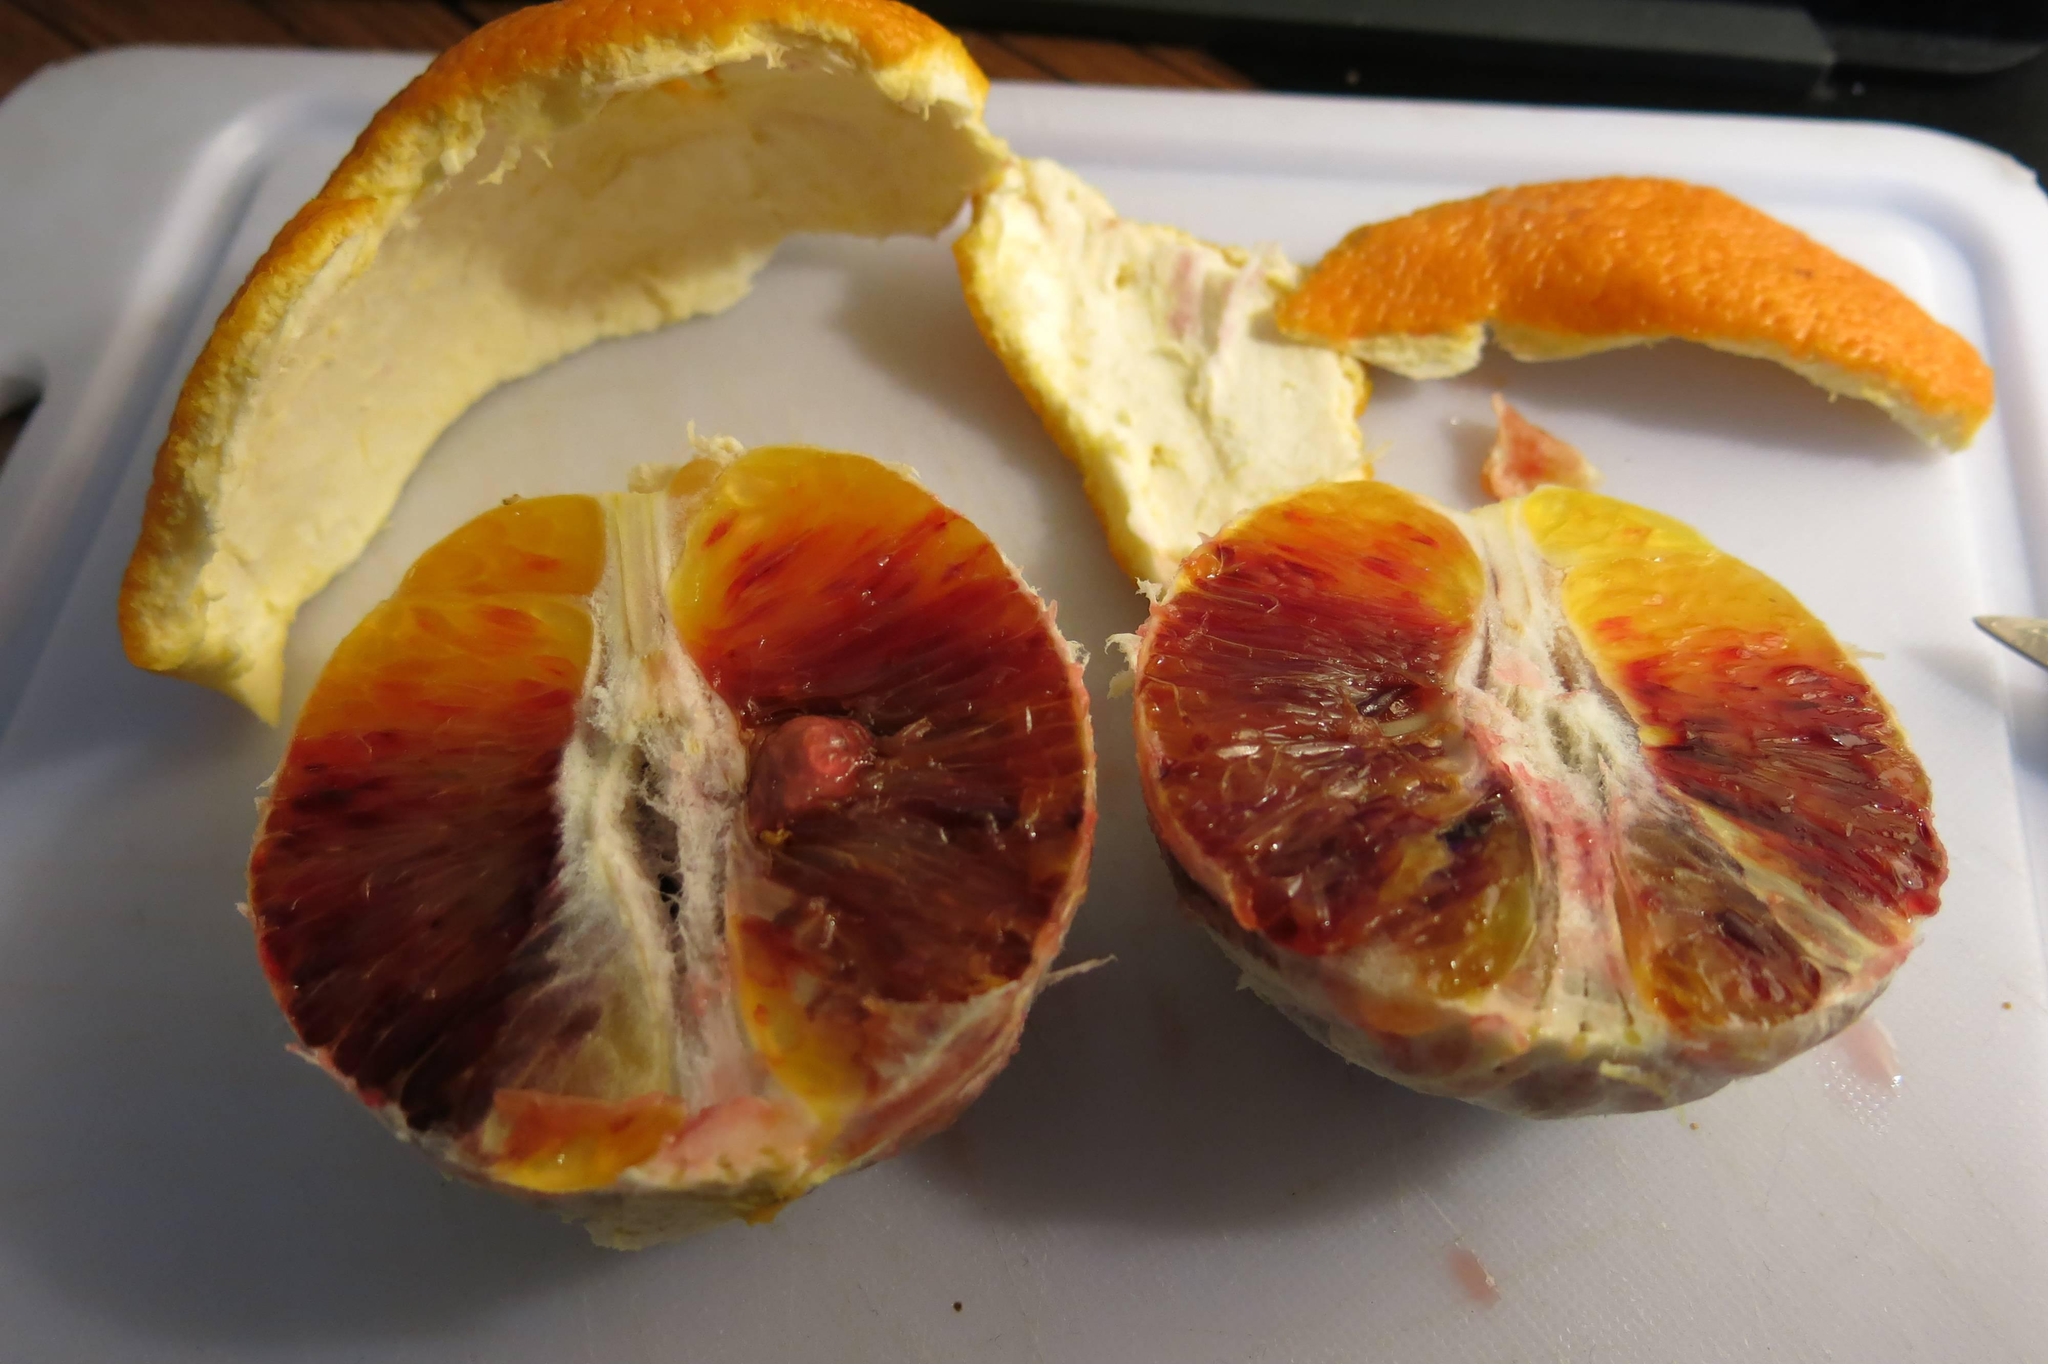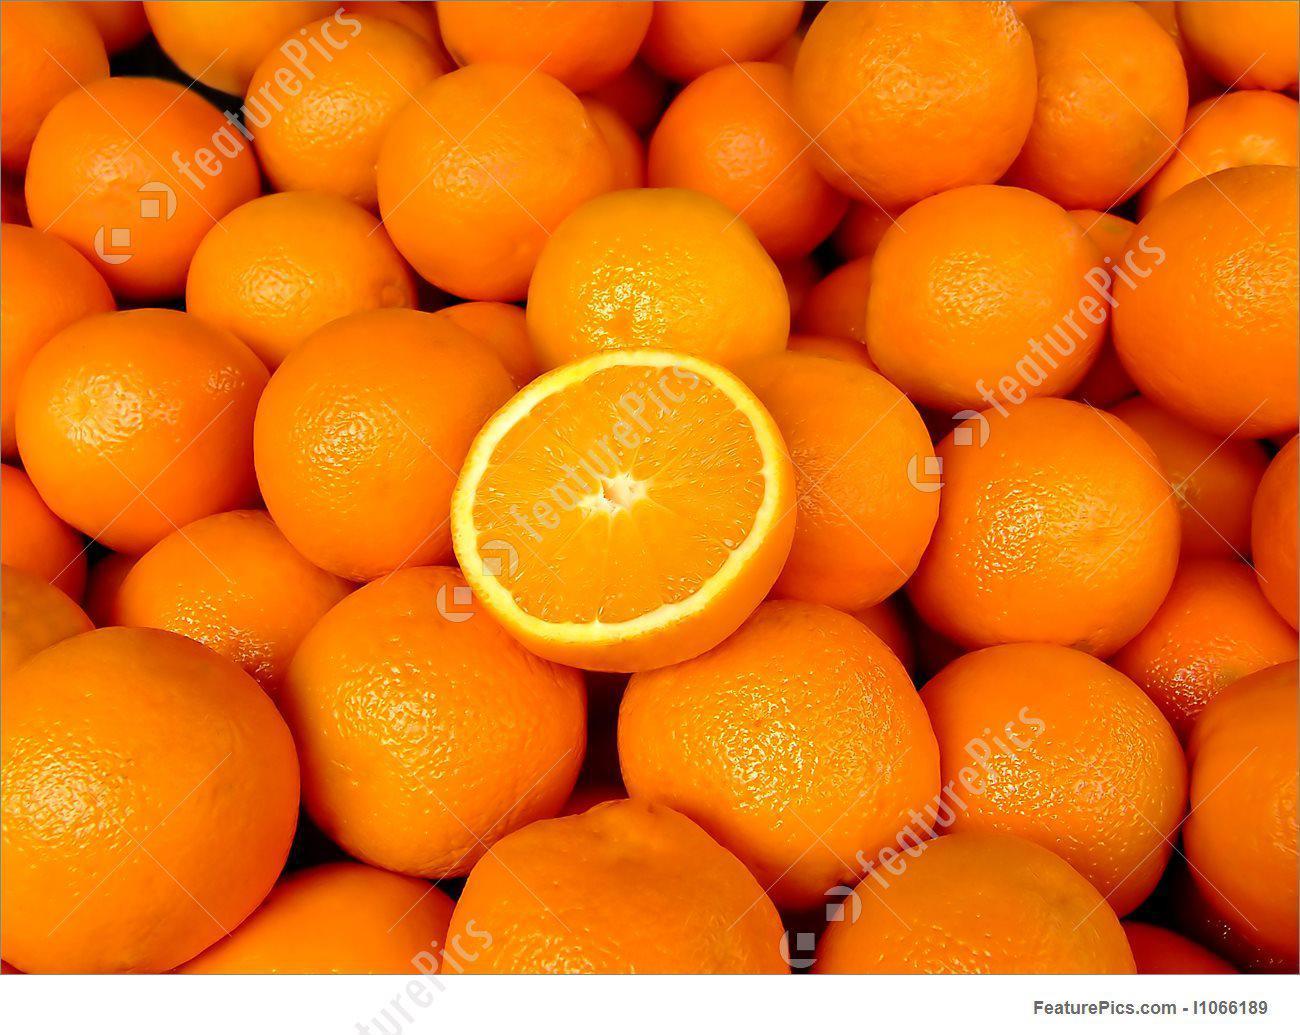The first image is the image on the left, the second image is the image on the right. For the images displayed, is the sentence "One image has exactly one and a half oranges." factually correct? Answer yes or no. No. 